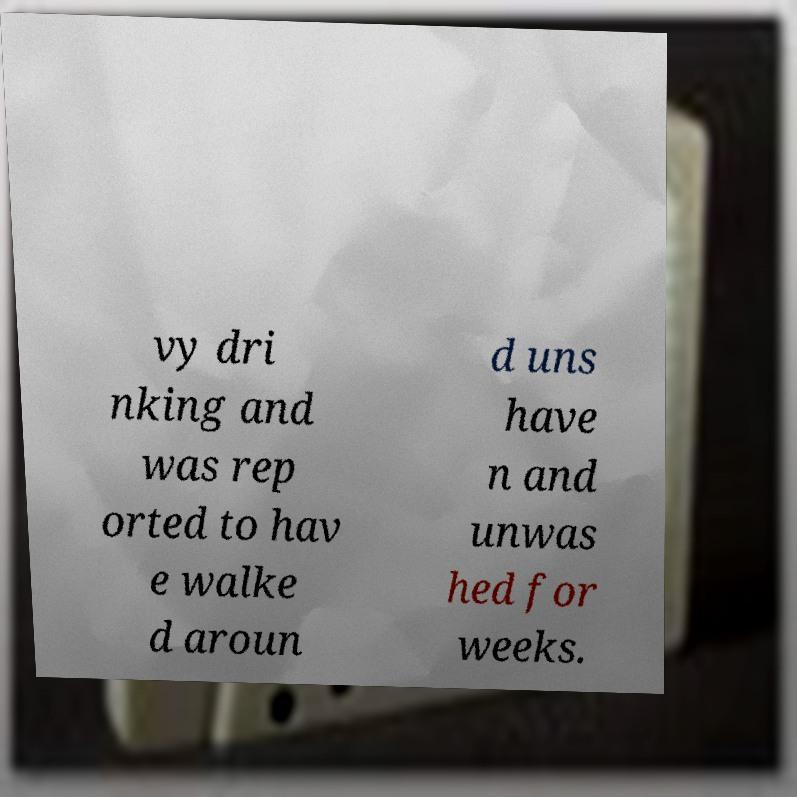Can you accurately transcribe the text from the provided image for me? vy dri nking and was rep orted to hav e walke d aroun d uns have n and unwas hed for weeks. 